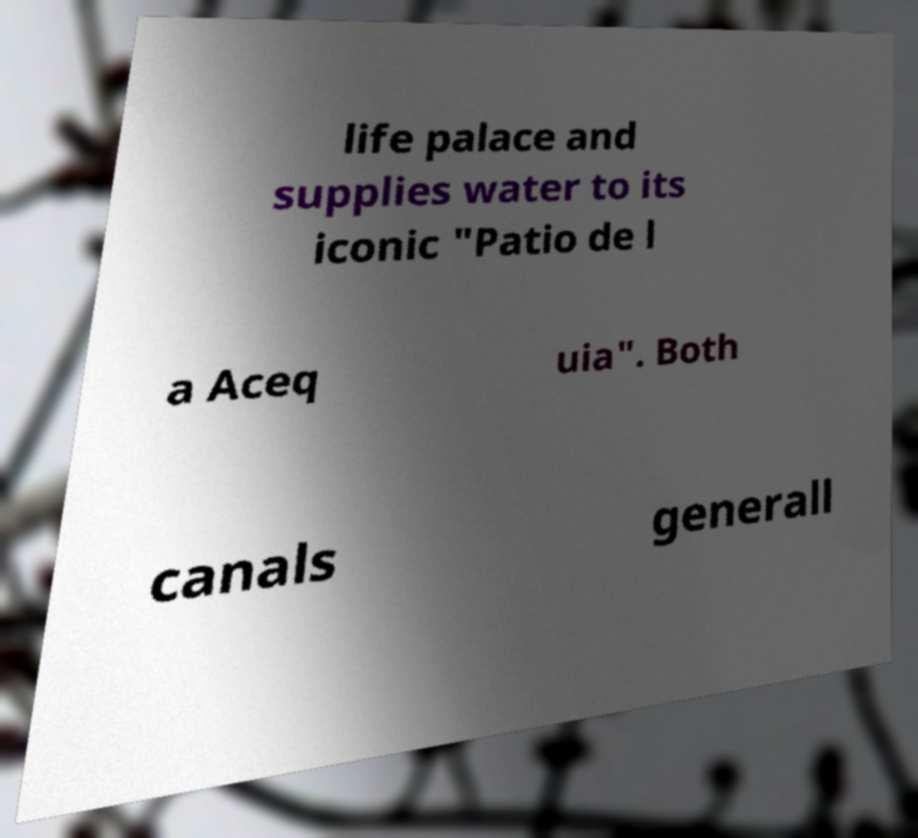Can you read and provide the text displayed in the image?This photo seems to have some interesting text. Can you extract and type it out for me? life palace and supplies water to its iconic "Patio de l a Aceq uia". Both canals generall 